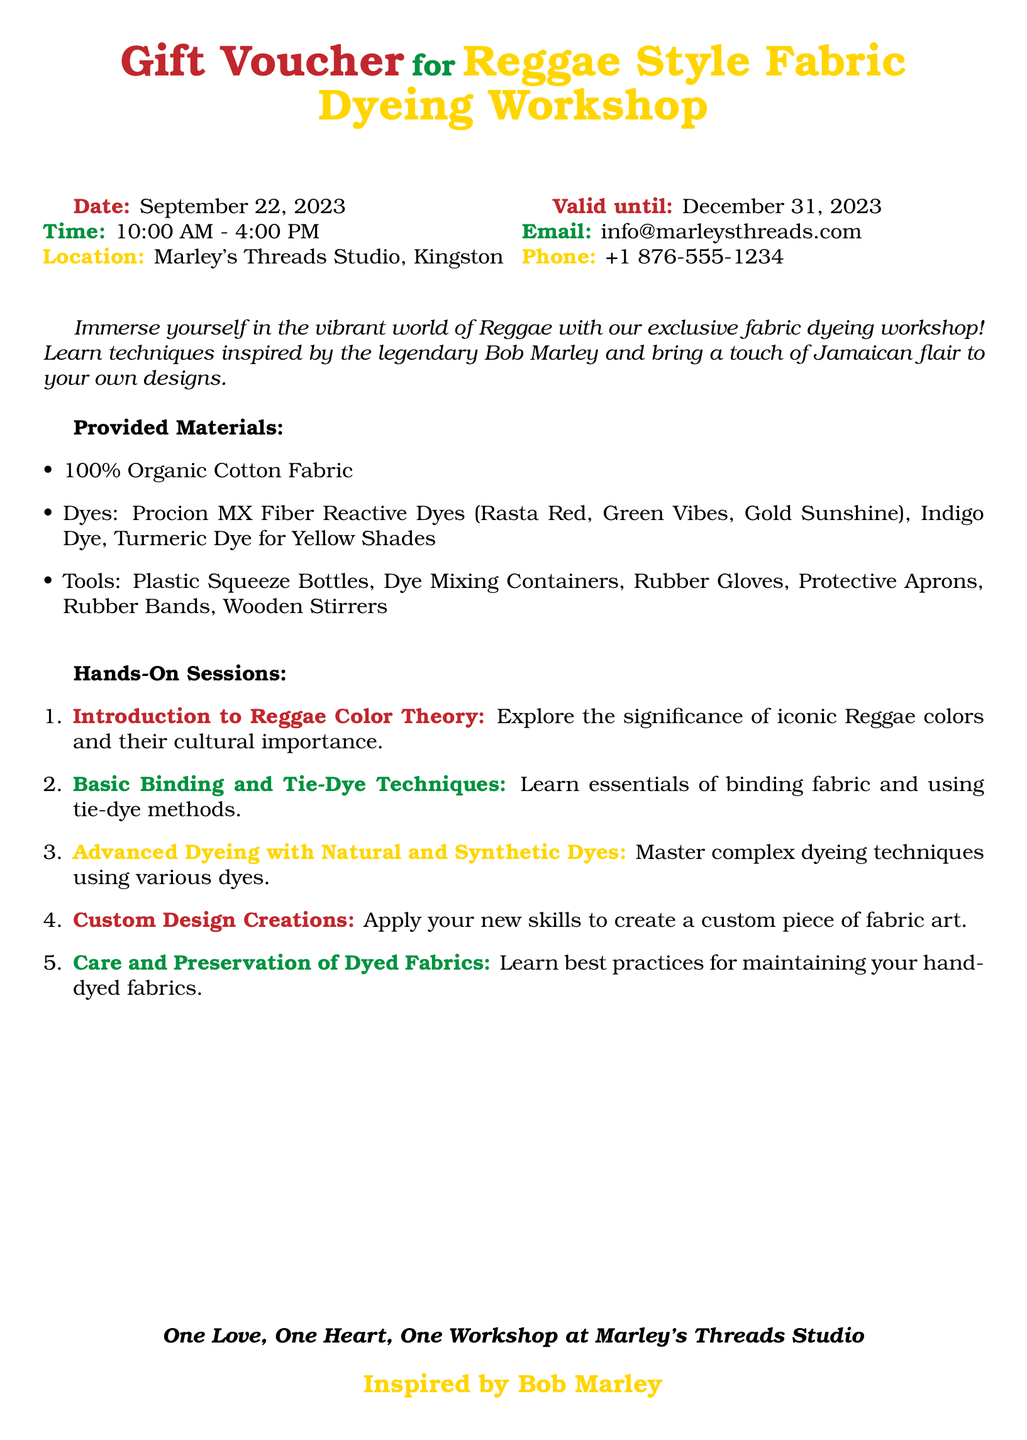What is the location of the workshop? The location of the workshop is mentioned in the document as Marley's Threads Studio in Kingston.
Answer: Marley's Threads Studio, Kingston What are the workshop hours? The workshop hours are specified in the document as from 10:00 AM to 4:00 PM.
Answer: 10:00 AM - 4:00 PM What is the date of the workshop? The date of the workshop is provided in the document as September 22, 2023.
Answer: September 22, 2023 What is the validity date of the gift voucher? The document states that the gift voucher is valid until December 31, 2023.
Answer: December 31, 2023 Which natural dye is mentioned for yellow shades? The document lists turmeric dye as a natural dye used for yellow shades.
Answer: Turmeric Dye What is the first hands-on session about? The first hands-on session is an introduction to Reggae color theory, which is outlined in the document.
Answer: Introduction to Reggae Color Theory What type of fabric is provided for the workshop? The document specifies that 100% organic cotton fabric is provided for the workshop.
Answer: 100% Organic Cotton Fabric What should participants learn to preserve their fabrics? The document indicates that participants will learn best practices for maintaining their hand-dyed fabrics.
Answer: Care and Preservation of Dyed Fabrics What is the email address for inquiries? The email address for inquiries is found in the document as info@marleysthreads.com.
Answer: info@marleysthreads.com 